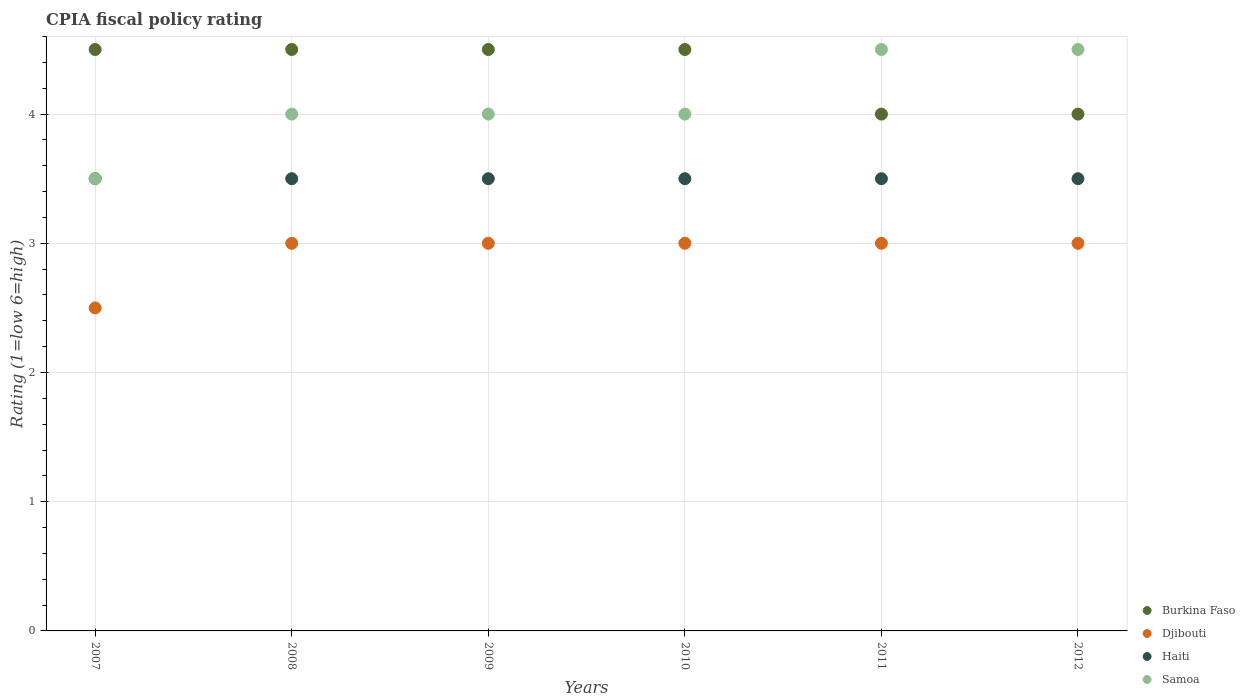How many different coloured dotlines are there?
Your response must be concise. 4. Is the number of dotlines equal to the number of legend labels?
Make the answer very short. Yes. Across all years, what is the minimum CPIA rating in Djibouti?
Offer a terse response. 2.5. In which year was the CPIA rating in Haiti minimum?
Provide a succinct answer. 2007. What is the average CPIA rating in Haiti per year?
Provide a short and direct response. 3.5. What is the ratio of the CPIA rating in Haiti in 2010 to that in 2011?
Provide a short and direct response. 1. Is the difference between the CPIA rating in Samoa in 2009 and 2012 greater than the difference between the CPIA rating in Haiti in 2009 and 2012?
Your response must be concise. No. What is the difference between the highest and the second highest CPIA rating in Burkina Faso?
Give a very brief answer. 0. What is the difference between the highest and the lowest CPIA rating in Samoa?
Your answer should be very brief. 1. Is it the case that in every year, the sum of the CPIA rating in Haiti and CPIA rating in Burkina Faso  is greater than the CPIA rating in Djibouti?
Offer a very short reply. Yes. Is the CPIA rating in Samoa strictly greater than the CPIA rating in Burkina Faso over the years?
Provide a short and direct response. No. How many legend labels are there?
Make the answer very short. 4. What is the title of the graph?
Keep it short and to the point. CPIA fiscal policy rating. Does "Venezuela" appear as one of the legend labels in the graph?
Make the answer very short. No. What is the label or title of the Y-axis?
Make the answer very short. Rating (1=low 6=high). What is the Rating (1=low 6=high) of Haiti in 2007?
Provide a succinct answer. 3.5. What is the Rating (1=low 6=high) of Samoa in 2007?
Provide a short and direct response. 3.5. What is the Rating (1=low 6=high) in Haiti in 2008?
Give a very brief answer. 3.5. What is the Rating (1=low 6=high) in Samoa in 2008?
Keep it short and to the point. 4. What is the Rating (1=low 6=high) in Haiti in 2009?
Your response must be concise. 3.5. What is the Rating (1=low 6=high) in Samoa in 2009?
Offer a very short reply. 4. What is the Rating (1=low 6=high) of Burkina Faso in 2010?
Your answer should be compact. 4.5. What is the Rating (1=low 6=high) of Haiti in 2010?
Your answer should be very brief. 3.5. What is the Rating (1=low 6=high) of Samoa in 2010?
Provide a succinct answer. 4. What is the Rating (1=low 6=high) in Burkina Faso in 2012?
Offer a terse response. 4. What is the Rating (1=low 6=high) in Samoa in 2012?
Your response must be concise. 4.5. Across all years, what is the maximum Rating (1=low 6=high) in Haiti?
Your answer should be compact. 3.5. Across all years, what is the minimum Rating (1=low 6=high) of Burkina Faso?
Keep it short and to the point. 4. Across all years, what is the minimum Rating (1=low 6=high) of Haiti?
Provide a short and direct response. 3.5. What is the total Rating (1=low 6=high) of Djibouti in the graph?
Provide a succinct answer. 17.5. What is the difference between the Rating (1=low 6=high) in Burkina Faso in 2007 and that in 2008?
Offer a terse response. 0. What is the difference between the Rating (1=low 6=high) of Haiti in 2007 and that in 2008?
Your response must be concise. 0. What is the difference between the Rating (1=low 6=high) of Haiti in 2007 and that in 2009?
Your answer should be very brief. 0. What is the difference between the Rating (1=low 6=high) of Samoa in 2007 and that in 2010?
Offer a very short reply. -0.5. What is the difference between the Rating (1=low 6=high) in Burkina Faso in 2007 and that in 2011?
Offer a very short reply. 0.5. What is the difference between the Rating (1=low 6=high) in Djibouti in 2007 and that in 2011?
Your response must be concise. -0.5. What is the difference between the Rating (1=low 6=high) in Haiti in 2007 and that in 2011?
Provide a succinct answer. 0. What is the difference between the Rating (1=low 6=high) in Djibouti in 2007 and that in 2012?
Provide a succinct answer. -0.5. What is the difference between the Rating (1=low 6=high) in Djibouti in 2008 and that in 2009?
Ensure brevity in your answer.  0. What is the difference between the Rating (1=low 6=high) in Haiti in 2008 and that in 2009?
Offer a terse response. 0. What is the difference between the Rating (1=low 6=high) of Burkina Faso in 2008 and that in 2010?
Provide a succinct answer. 0. What is the difference between the Rating (1=low 6=high) in Samoa in 2008 and that in 2010?
Keep it short and to the point. 0. What is the difference between the Rating (1=low 6=high) in Djibouti in 2008 and that in 2011?
Offer a terse response. 0. What is the difference between the Rating (1=low 6=high) in Samoa in 2008 and that in 2011?
Your answer should be very brief. -0.5. What is the difference between the Rating (1=low 6=high) of Djibouti in 2008 and that in 2012?
Provide a succinct answer. 0. What is the difference between the Rating (1=low 6=high) in Burkina Faso in 2009 and that in 2010?
Provide a succinct answer. 0. What is the difference between the Rating (1=low 6=high) in Haiti in 2009 and that in 2010?
Offer a terse response. 0. What is the difference between the Rating (1=low 6=high) of Burkina Faso in 2009 and that in 2011?
Provide a short and direct response. 0.5. What is the difference between the Rating (1=low 6=high) of Djibouti in 2009 and that in 2012?
Ensure brevity in your answer.  0. What is the difference between the Rating (1=low 6=high) of Haiti in 2009 and that in 2012?
Provide a succinct answer. 0. What is the difference between the Rating (1=low 6=high) of Samoa in 2009 and that in 2012?
Offer a terse response. -0.5. What is the difference between the Rating (1=low 6=high) in Burkina Faso in 2010 and that in 2011?
Provide a short and direct response. 0.5. What is the difference between the Rating (1=low 6=high) in Djibouti in 2010 and that in 2011?
Make the answer very short. 0. What is the difference between the Rating (1=low 6=high) in Haiti in 2010 and that in 2011?
Offer a terse response. 0. What is the difference between the Rating (1=low 6=high) in Samoa in 2010 and that in 2011?
Provide a short and direct response. -0.5. What is the difference between the Rating (1=low 6=high) in Haiti in 2010 and that in 2012?
Keep it short and to the point. 0. What is the difference between the Rating (1=low 6=high) in Djibouti in 2011 and that in 2012?
Offer a very short reply. 0. What is the difference between the Rating (1=low 6=high) of Haiti in 2011 and that in 2012?
Keep it short and to the point. 0. What is the difference between the Rating (1=low 6=high) of Samoa in 2011 and that in 2012?
Offer a terse response. 0. What is the difference between the Rating (1=low 6=high) of Burkina Faso in 2007 and the Rating (1=low 6=high) of Samoa in 2009?
Give a very brief answer. 0.5. What is the difference between the Rating (1=low 6=high) in Djibouti in 2007 and the Rating (1=low 6=high) in Haiti in 2009?
Give a very brief answer. -1. What is the difference between the Rating (1=low 6=high) of Djibouti in 2007 and the Rating (1=low 6=high) of Samoa in 2009?
Keep it short and to the point. -1.5. What is the difference between the Rating (1=low 6=high) of Burkina Faso in 2007 and the Rating (1=low 6=high) of Djibouti in 2010?
Provide a short and direct response. 1.5. What is the difference between the Rating (1=low 6=high) of Djibouti in 2007 and the Rating (1=low 6=high) of Haiti in 2010?
Your answer should be compact. -1. What is the difference between the Rating (1=low 6=high) of Burkina Faso in 2007 and the Rating (1=low 6=high) of Haiti in 2011?
Your answer should be compact. 1. What is the difference between the Rating (1=low 6=high) in Burkina Faso in 2007 and the Rating (1=low 6=high) in Samoa in 2011?
Your answer should be very brief. 0. What is the difference between the Rating (1=low 6=high) in Haiti in 2007 and the Rating (1=low 6=high) in Samoa in 2011?
Give a very brief answer. -1. What is the difference between the Rating (1=low 6=high) of Burkina Faso in 2007 and the Rating (1=low 6=high) of Djibouti in 2012?
Keep it short and to the point. 1.5. What is the difference between the Rating (1=low 6=high) of Djibouti in 2007 and the Rating (1=low 6=high) of Haiti in 2012?
Keep it short and to the point. -1. What is the difference between the Rating (1=low 6=high) in Haiti in 2007 and the Rating (1=low 6=high) in Samoa in 2012?
Keep it short and to the point. -1. What is the difference between the Rating (1=low 6=high) of Burkina Faso in 2008 and the Rating (1=low 6=high) of Djibouti in 2009?
Provide a succinct answer. 1.5. What is the difference between the Rating (1=low 6=high) in Djibouti in 2008 and the Rating (1=low 6=high) in Haiti in 2009?
Give a very brief answer. -0.5. What is the difference between the Rating (1=low 6=high) in Haiti in 2008 and the Rating (1=low 6=high) in Samoa in 2009?
Your answer should be compact. -0.5. What is the difference between the Rating (1=low 6=high) in Burkina Faso in 2008 and the Rating (1=low 6=high) in Haiti in 2010?
Give a very brief answer. 1. What is the difference between the Rating (1=low 6=high) of Djibouti in 2008 and the Rating (1=low 6=high) of Haiti in 2010?
Provide a short and direct response. -0.5. What is the difference between the Rating (1=low 6=high) in Djibouti in 2008 and the Rating (1=low 6=high) in Samoa in 2010?
Keep it short and to the point. -1. What is the difference between the Rating (1=low 6=high) in Burkina Faso in 2008 and the Rating (1=low 6=high) in Djibouti in 2011?
Provide a succinct answer. 1.5. What is the difference between the Rating (1=low 6=high) of Djibouti in 2008 and the Rating (1=low 6=high) of Samoa in 2011?
Offer a very short reply. -1.5. What is the difference between the Rating (1=low 6=high) in Burkina Faso in 2008 and the Rating (1=low 6=high) in Haiti in 2012?
Keep it short and to the point. 1. What is the difference between the Rating (1=low 6=high) in Djibouti in 2008 and the Rating (1=low 6=high) in Samoa in 2012?
Ensure brevity in your answer.  -1.5. What is the difference between the Rating (1=low 6=high) in Burkina Faso in 2009 and the Rating (1=low 6=high) in Haiti in 2010?
Ensure brevity in your answer.  1. What is the difference between the Rating (1=low 6=high) in Djibouti in 2009 and the Rating (1=low 6=high) in Samoa in 2010?
Offer a very short reply. -1. What is the difference between the Rating (1=low 6=high) of Burkina Faso in 2009 and the Rating (1=low 6=high) of Djibouti in 2011?
Make the answer very short. 1.5. What is the difference between the Rating (1=low 6=high) in Djibouti in 2009 and the Rating (1=low 6=high) in Haiti in 2011?
Offer a terse response. -0.5. What is the difference between the Rating (1=low 6=high) of Djibouti in 2009 and the Rating (1=low 6=high) of Samoa in 2011?
Provide a succinct answer. -1.5. What is the difference between the Rating (1=low 6=high) in Haiti in 2009 and the Rating (1=low 6=high) in Samoa in 2011?
Offer a very short reply. -1. What is the difference between the Rating (1=low 6=high) in Djibouti in 2009 and the Rating (1=low 6=high) in Haiti in 2012?
Offer a very short reply. -0.5. What is the difference between the Rating (1=low 6=high) of Djibouti in 2009 and the Rating (1=low 6=high) of Samoa in 2012?
Your answer should be compact. -1.5. What is the difference between the Rating (1=low 6=high) of Burkina Faso in 2010 and the Rating (1=low 6=high) of Haiti in 2011?
Your answer should be compact. 1. What is the difference between the Rating (1=low 6=high) in Burkina Faso in 2010 and the Rating (1=low 6=high) in Samoa in 2011?
Give a very brief answer. 0. What is the difference between the Rating (1=low 6=high) of Djibouti in 2010 and the Rating (1=low 6=high) of Samoa in 2011?
Make the answer very short. -1.5. What is the difference between the Rating (1=low 6=high) of Burkina Faso in 2010 and the Rating (1=low 6=high) of Djibouti in 2012?
Make the answer very short. 1.5. What is the difference between the Rating (1=low 6=high) of Djibouti in 2010 and the Rating (1=low 6=high) of Haiti in 2012?
Keep it short and to the point. -0.5. What is the difference between the Rating (1=low 6=high) in Djibouti in 2010 and the Rating (1=low 6=high) in Samoa in 2012?
Give a very brief answer. -1.5. What is the difference between the Rating (1=low 6=high) of Burkina Faso in 2011 and the Rating (1=low 6=high) of Djibouti in 2012?
Provide a short and direct response. 1. What is the difference between the Rating (1=low 6=high) of Burkina Faso in 2011 and the Rating (1=low 6=high) of Samoa in 2012?
Give a very brief answer. -0.5. What is the average Rating (1=low 6=high) of Burkina Faso per year?
Keep it short and to the point. 4.33. What is the average Rating (1=low 6=high) in Djibouti per year?
Provide a short and direct response. 2.92. What is the average Rating (1=low 6=high) of Haiti per year?
Your response must be concise. 3.5. What is the average Rating (1=low 6=high) of Samoa per year?
Keep it short and to the point. 4.08. In the year 2007, what is the difference between the Rating (1=low 6=high) in Burkina Faso and Rating (1=low 6=high) in Djibouti?
Offer a terse response. 2. In the year 2007, what is the difference between the Rating (1=low 6=high) in Burkina Faso and Rating (1=low 6=high) in Haiti?
Offer a terse response. 1. In the year 2008, what is the difference between the Rating (1=low 6=high) of Burkina Faso and Rating (1=low 6=high) of Djibouti?
Provide a short and direct response. 1.5. In the year 2008, what is the difference between the Rating (1=low 6=high) in Burkina Faso and Rating (1=low 6=high) in Haiti?
Keep it short and to the point. 1. In the year 2008, what is the difference between the Rating (1=low 6=high) in Burkina Faso and Rating (1=low 6=high) in Samoa?
Ensure brevity in your answer.  0.5. In the year 2009, what is the difference between the Rating (1=low 6=high) in Burkina Faso and Rating (1=low 6=high) in Djibouti?
Provide a succinct answer. 1.5. In the year 2009, what is the difference between the Rating (1=low 6=high) of Djibouti and Rating (1=low 6=high) of Haiti?
Offer a terse response. -0.5. In the year 2010, what is the difference between the Rating (1=low 6=high) in Burkina Faso and Rating (1=low 6=high) in Djibouti?
Ensure brevity in your answer.  1.5. In the year 2010, what is the difference between the Rating (1=low 6=high) of Burkina Faso and Rating (1=low 6=high) of Samoa?
Offer a terse response. 0.5. In the year 2010, what is the difference between the Rating (1=low 6=high) in Djibouti and Rating (1=low 6=high) in Haiti?
Provide a short and direct response. -0.5. In the year 2010, what is the difference between the Rating (1=low 6=high) in Haiti and Rating (1=low 6=high) in Samoa?
Provide a succinct answer. -0.5. In the year 2011, what is the difference between the Rating (1=low 6=high) of Djibouti and Rating (1=low 6=high) of Haiti?
Make the answer very short. -0.5. In the year 2012, what is the difference between the Rating (1=low 6=high) of Burkina Faso and Rating (1=low 6=high) of Djibouti?
Your answer should be compact. 1. In the year 2012, what is the difference between the Rating (1=low 6=high) of Burkina Faso and Rating (1=low 6=high) of Samoa?
Make the answer very short. -0.5. In the year 2012, what is the difference between the Rating (1=low 6=high) of Haiti and Rating (1=low 6=high) of Samoa?
Provide a short and direct response. -1. What is the ratio of the Rating (1=low 6=high) of Burkina Faso in 2007 to that in 2008?
Your answer should be very brief. 1. What is the ratio of the Rating (1=low 6=high) in Samoa in 2007 to that in 2008?
Keep it short and to the point. 0.88. What is the ratio of the Rating (1=low 6=high) in Djibouti in 2007 to that in 2009?
Make the answer very short. 0.83. What is the ratio of the Rating (1=low 6=high) in Haiti in 2007 to that in 2009?
Provide a short and direct response. 1. What is the ratio of the Rating (1=low 6=high) in Samoa in 2007 to that in 2009?
Offer a terse response. 0.88. What is the ratio of the Rating (1=low 6=high) in Djibouti in 2007 to that in 2010?
Provide a succinct answer. 0.83. What is the ratio of the Rating (1=low 6=high) in Haiti in 2007 to that in 2010?
Your response must be concise. 1. What is the ratio of the Rating (1=low 6=high) in Samoa in 2007 to that in 2011?
Make the answer very short. 0.78. What is the ratio of the Rating (1=low 6=high) of Burkina Faso in 2007 to that in 2012?
Your answer should be very brief. 1.12. What is the ratio of the Rating (1=low 6=high) in Djibouti in 2007 to that in 2012?
Your answer should be very brief. 0.83. What is the ratio of the Rating (1=low 6=high) in Haiti in 2007 to that in 2012?
Your answer should be very brief. 1. What is the ratio of the Rating (1=low 6=high) of Djibouti in 2008 to that in 2009?
Ensure brevity in your answer.  1. What is the ratio of the Rating (1=low 6=high) of Samoa in 2008 to that in 2009?
Ensure brevity in your answer.  1. What is the ratio of the Rating (1=low 6=high) of Djibouti in 2008 to that in 2010?
Your answer should be compact. 1. What is the ratio of the Rating (1=low 6=high) in Haiti in 2008 to that in 2010?
Your answer should be compact. 1. What is the ratio of the Rating (1=low 6=high) of Samoa in 2008 to that in 2011?
Offer a very short reply. 0.89. What is the ratio of the Rating (1=low 6=high) of Burkina Faso in 2008 to that in 2012?
Give a very brief answer. 1.12. What is the ratio of the Rating (1=low 6=high) in Burkina Faso in 2009 to that in 2010?
Provide a short and direct response. 1. What is the ratio of the Rating (1=low 6=high) of Djibouti in 2009 to that in 2010?
Provide a succinct answer. 1. What is the ratio of the Rating (1=low 6=high) in Djibouti in 2009 to that in 2011?
Provide a succinct answer. 1. What is the ratio of the Rating (1=low 6=high) in Haiti in 2009 to that in 2011?
Ensure brevity in your answer.  1. What is the ratio of the Rating (1=low 6=high) in Samoa in 2009 to that in 2011?
Make the answer very short. 0.89. What is the ratio of the Rating (1=low 6=high) in Djibouti in 2009 to that in 2012?
Ensure brevity in your answer.  1. What is the ratio of the Rating (1=low 6=high) in Haiti in 2009 to that in 2012?
Provide a succinct answer. 1. What is the ratio of the Rating (1=low 6=high) of Samoa in 2009 to that in 2012?
Your response must be concise. 0.89. What is the ratio of the Rating (1=low 6=high) in Burkina Faso in 2010 to that in 2011?
Make the answer very short. 1.12. What is the ratio of the Rating (1=low 6=high) in Samoa in 2010 to that in 2011?
Offer a very short reply. 0.89. What is the ratio of the Rating (1=low 6=high) in Burkina Faso in 2010 to that in 2012?
Offer a very short reply. 1.12. What is the ratio of the Rating (1=low 6=high) of Djibouti in 2010 to that in 2012?
Your answer should be very brief. 1. What is the ratio of the Rating (1=low 6=high) of Samoa in 2010 to that in 2012?
Ensure brevity in your answer.  0.89. What is the ratio of the Rating (1=low 6=high) in Burkina Faso in 2011 to that in 2012?
Your answer should be compact. 1. What is the ratio of the Rating (1=low 6=high) in Djibouti in 2011 to that in 2012?
Your answer should be very brief. 1. What is the difference between the highest and the second highest Rating (1=low 6=high) of Djibouti?
Offer a terse response. 0. What is the difference between the highest and the second highest Rating (1=low 6=high) in Samoa?
Offer a terse response. 0. What is the difference between the highest and the lowest Rating (1=low 6=high) in Burkina Faso?
Offer a very short reply. 0.5. What is the difference between the highest and the lowest Rating (1=low 6=high) in Djibouti?
Give a very brief answer. 0.5. What is the difference between the highest and the lowest Rating (1=low 6=high) in Haiti?
Your answer should be compact. 0. 